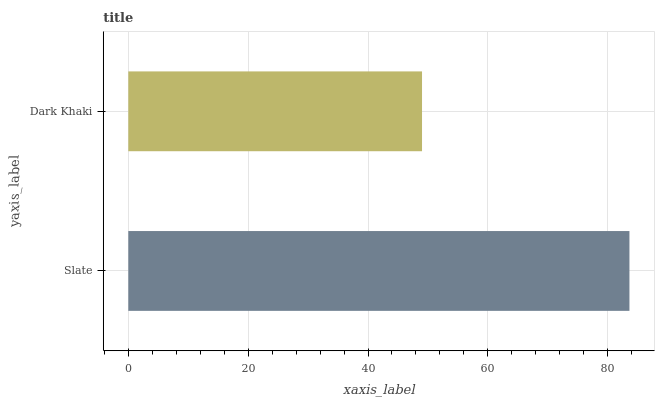Is Dark Khaki the minimum?
Answer yes or no. Yes. Is Slate the maximum?
Answer yes or no. Yes. Is Dark Khaki the maximum?
Answer yes or no. No. Is Slate greater than Dark Khaki?
Answer yes or no. Yes. Is Dark Khaki less than Slate?
Answer yes or no. Yes. Is Dark Khaki greater than Slate?
Answer yes or no. No. Is Slate less than Dark Khaki?
Answer yes or no. No. Is Slate the high median?
Answer yes or no. Yes. Is Dark Khaki the low median?
Answer yes or no. Yes. Is Dark Khaki the high median?
Answer yes or no. No. Is Slate the low median?
Answer yes or no. No. 